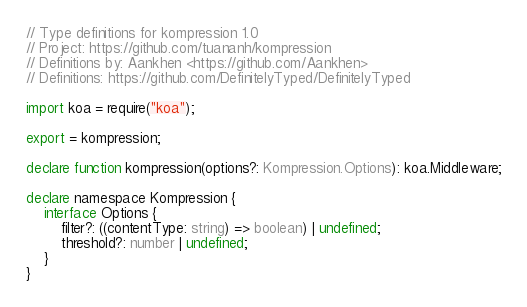<code> <loc_0><loc_0><loc_500><loc_500><_TypeScript_>// Type definitions for kompression 1.0
// Project: https://github.com/tuananh/kompression
// Definitions by: Aankhen <https://github.com/Aankhen>
// Definitions: https://github.com/DefinitelyTyped/DefinitelyTyped

import koa = require("koa");

export = kompression;

declare function kompression(options?: Kompression.Options): koa.Middleware;

declare namespace Kompression {
    interface Options {
        filter?: ((contentType: string) => boolean) | undefined;
        threshold?: number | undefined;
    }
}
</code> 